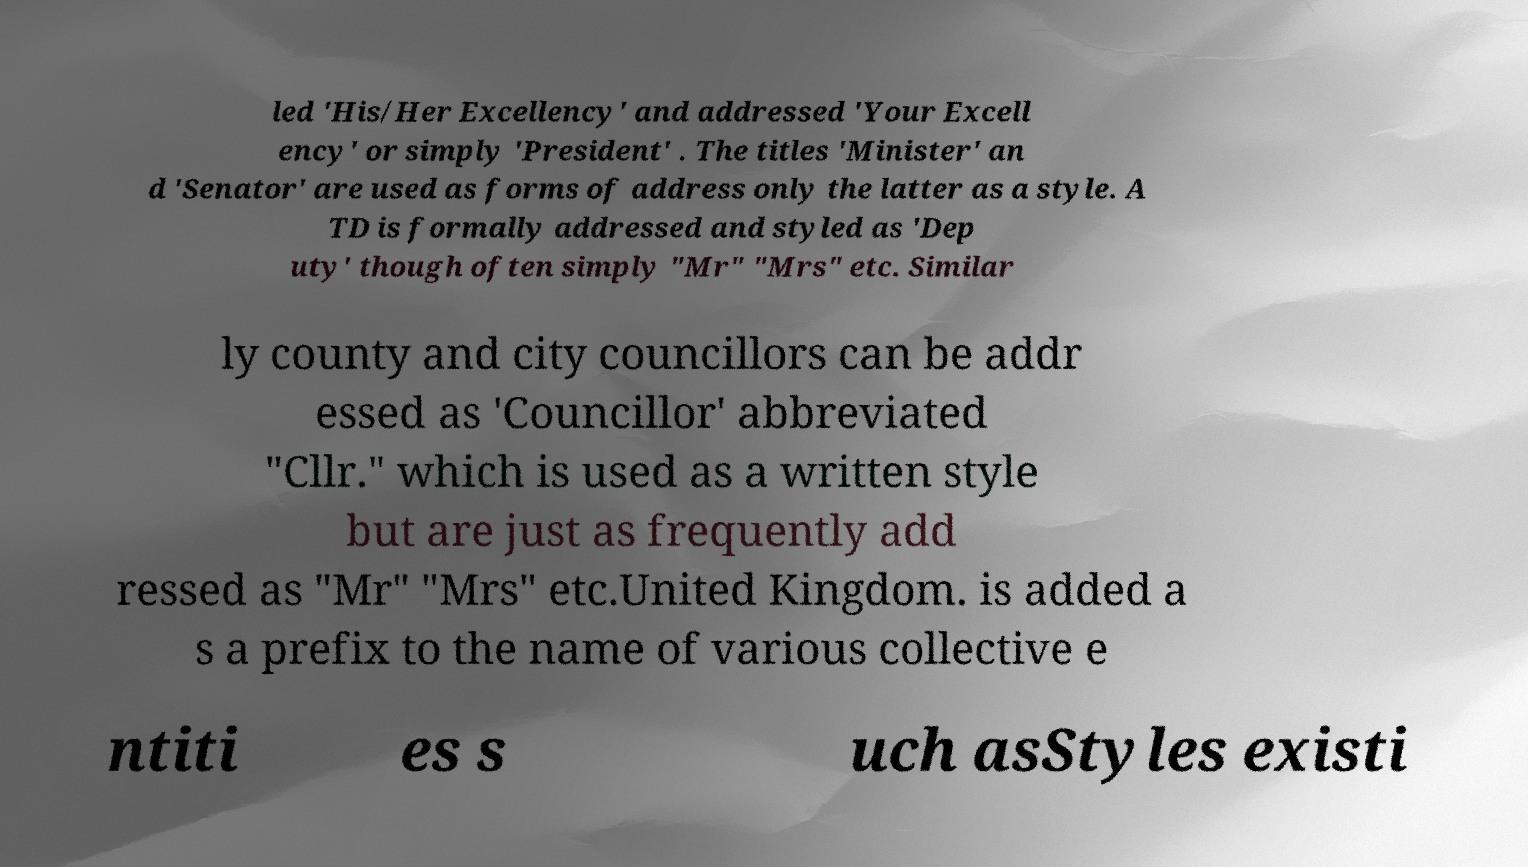Could you assist in decoding the text presented in this image and type it out clearly? led 'His/Her Excellency' and addressed 'Your Excell ency' or simply 'President' . The titles 'Minister' an d 'Senator' are used as forms of address only the latter as a style. A TD is formally addressed and styled as 'Dep uty' though often simply "Mr" "Mrs" etc. Similar ly county and city councillors can be addr essed as 'Councillor' abbreviated "Cllr." which is used as a written style but are just as frequently add ressed as "Mr" "Mrs" etc.United Kingdom. is added a s a prefix to the name of various collective e ntiti es s uch asStyles existi 